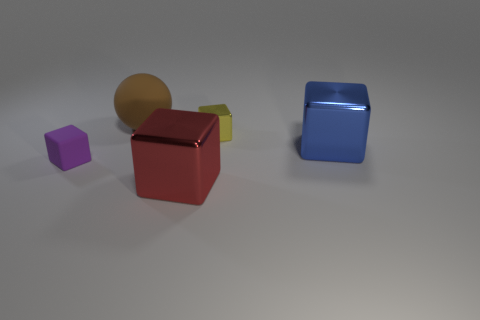What does the arrangement of objects suggest about their possible use or purpose? The arrangement of objects doesn't immediately suggest a specific use or purpose as they are placed randomly on a flat surface. However, they could represent a set of educational tools for teaching shapes and colors or perhaps they are simply decorative items that showcase the beauty of geometric forms and reflective materials. 